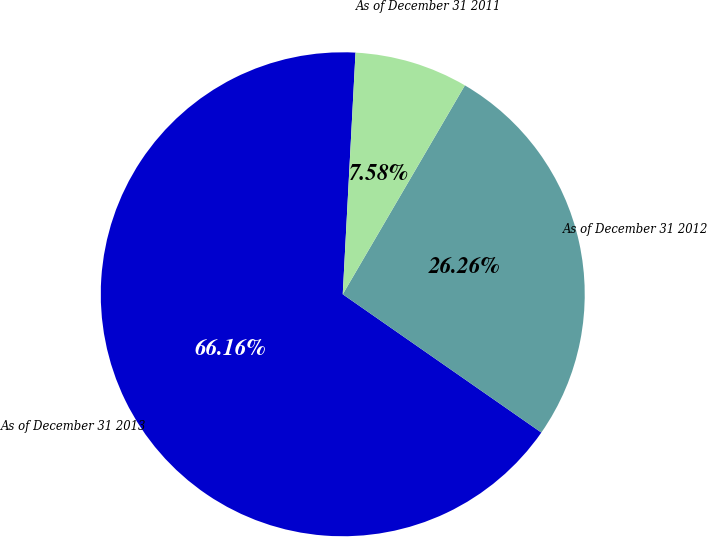<chart> <loc_0><loc_0><loc_500><loc_500><pie_chart><fcel>As of December 31 2013<fcel>As of December 31 2012<fcel>As of December 31 2011<nl><fcel>66.16%<fcel>26.26%<fcel>7.58%<nl></chart> 